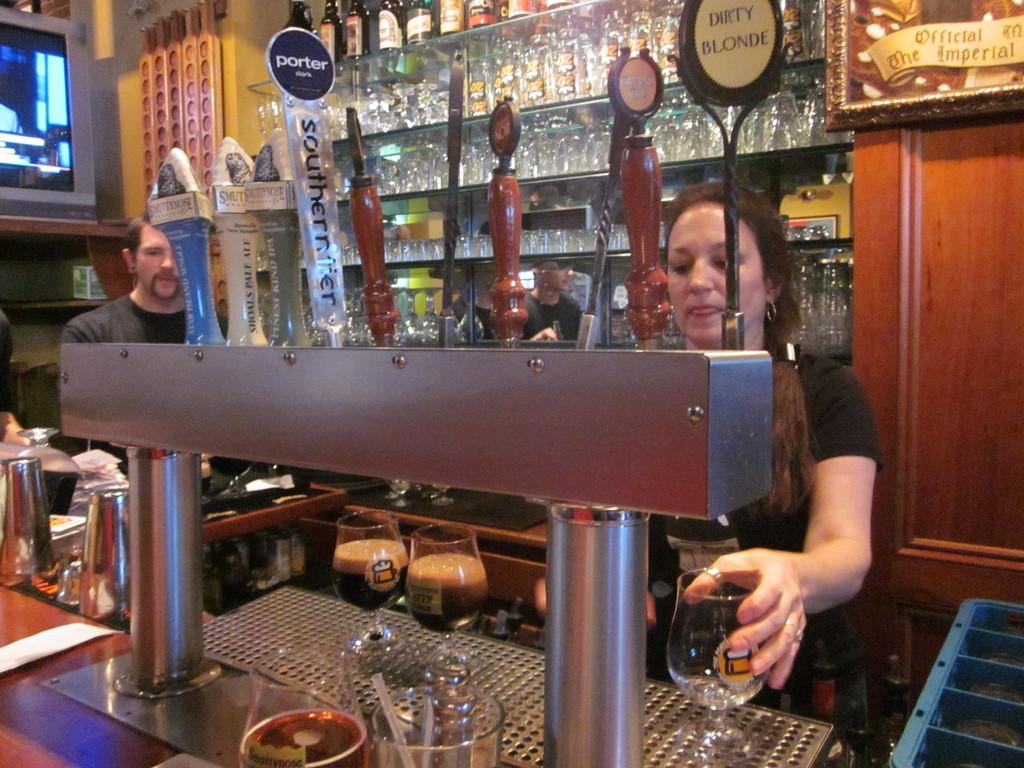<image>
Write a terse but informative summary of the picture. A bartender serving beer in front of several taps, two of which are Dirty Blonde and Porter Dark. 